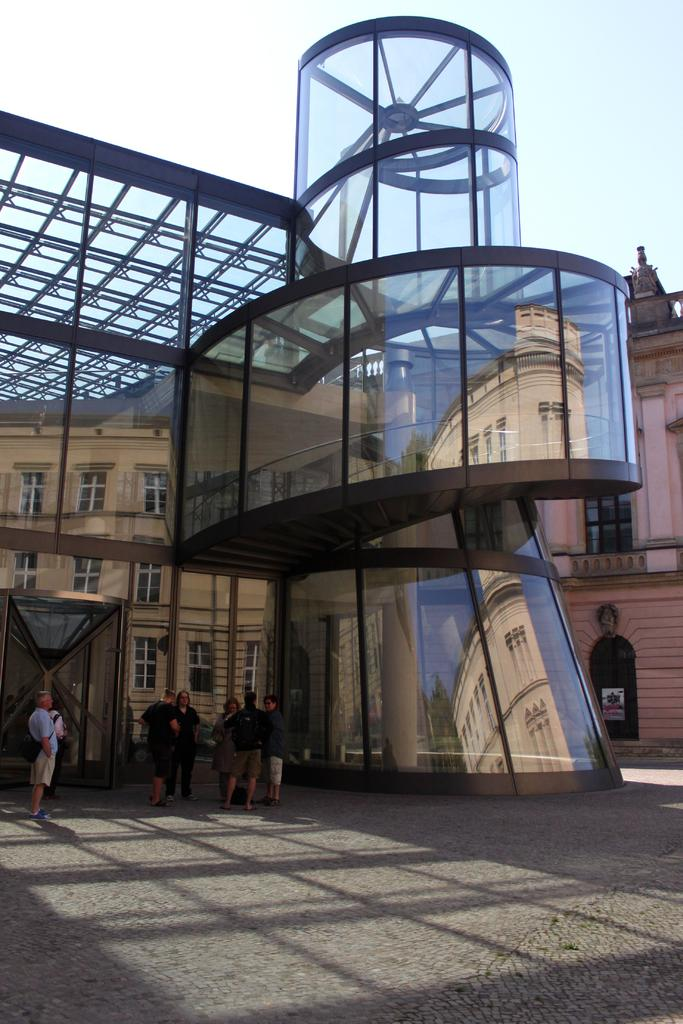What type of structures can be seen in the image? There are buildings in the image. What specific feature is present among the structures? There is a monument in the image. What else can be seen on the buildings or structures? There is a poster in the image. What is happening on the road in the image? People are present on the road in the image. What can be seen above the structures and people? The sky is visible at the top of the image. What color is the loss experienced by the people in the image? There is no mention of loss or any specific color associated with it in the image. Can you hear the voice of the monument in the image? The image is visual, and there is no mention of any voice or sound associated with the monument. 